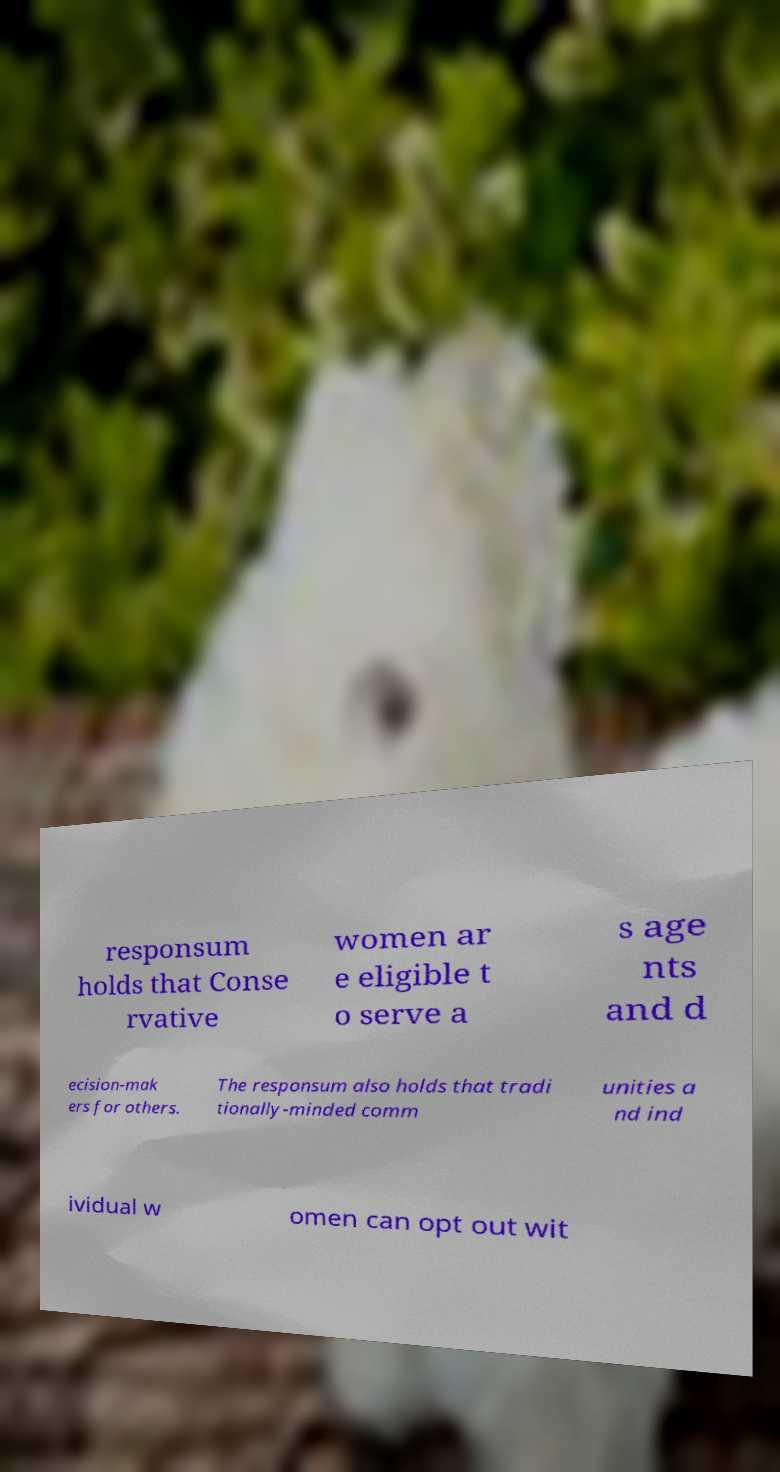What messages or text are displayed in this image? I need them in a readable, typed format. responsum holds that Conse rvative women ar e eligible t o serve a s age nts and d ecision-mak ers for others. The responsum also holds that tradi tionally-minded comm unities a nd ind ividual w omen can opt out wit 